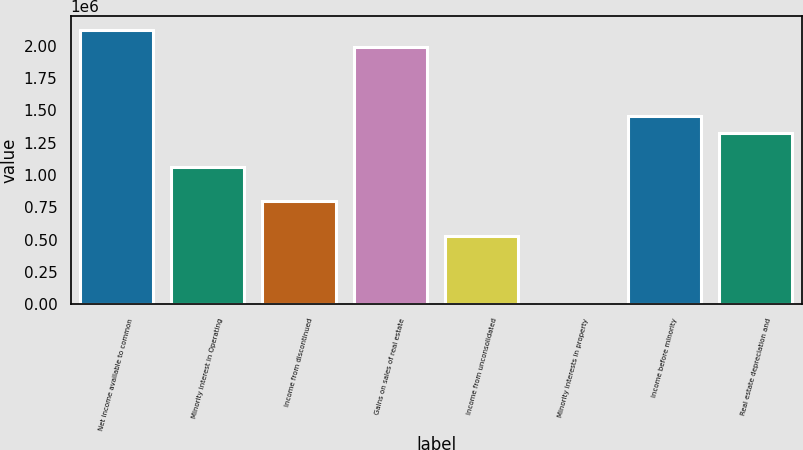<chart> <loc_0><loc_0><loc_500><loc_500><bar_chart><fcel>Net income available to common<fcel>Minority interest in Operating<fcel>Income from discontinued<fcel>Gains on sales of real estate<fcel>Income from unconsolidated<fcel>Minority interests in property<fcel>Income before minority<fcel>Real estate depreciation and<nl><fcel>2.11945e+06<fcel>1.05977e+06<fcel>794848<fcel>1.98699e+06<fcel>529926<fcel>84<fcel>1.45715e+06<fcel>1.32469e+06<nl></chart> 